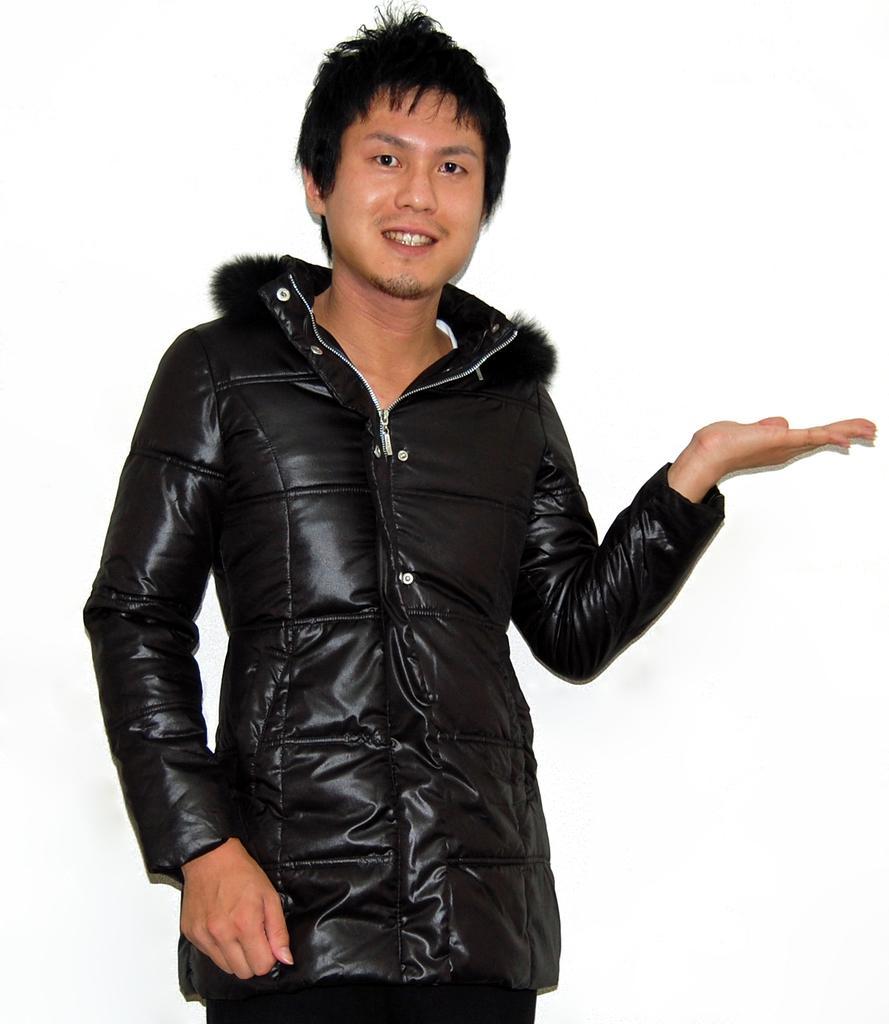Could you give a brief overview of what you see in this image? In this image a man. He is wearing black color jacket. 